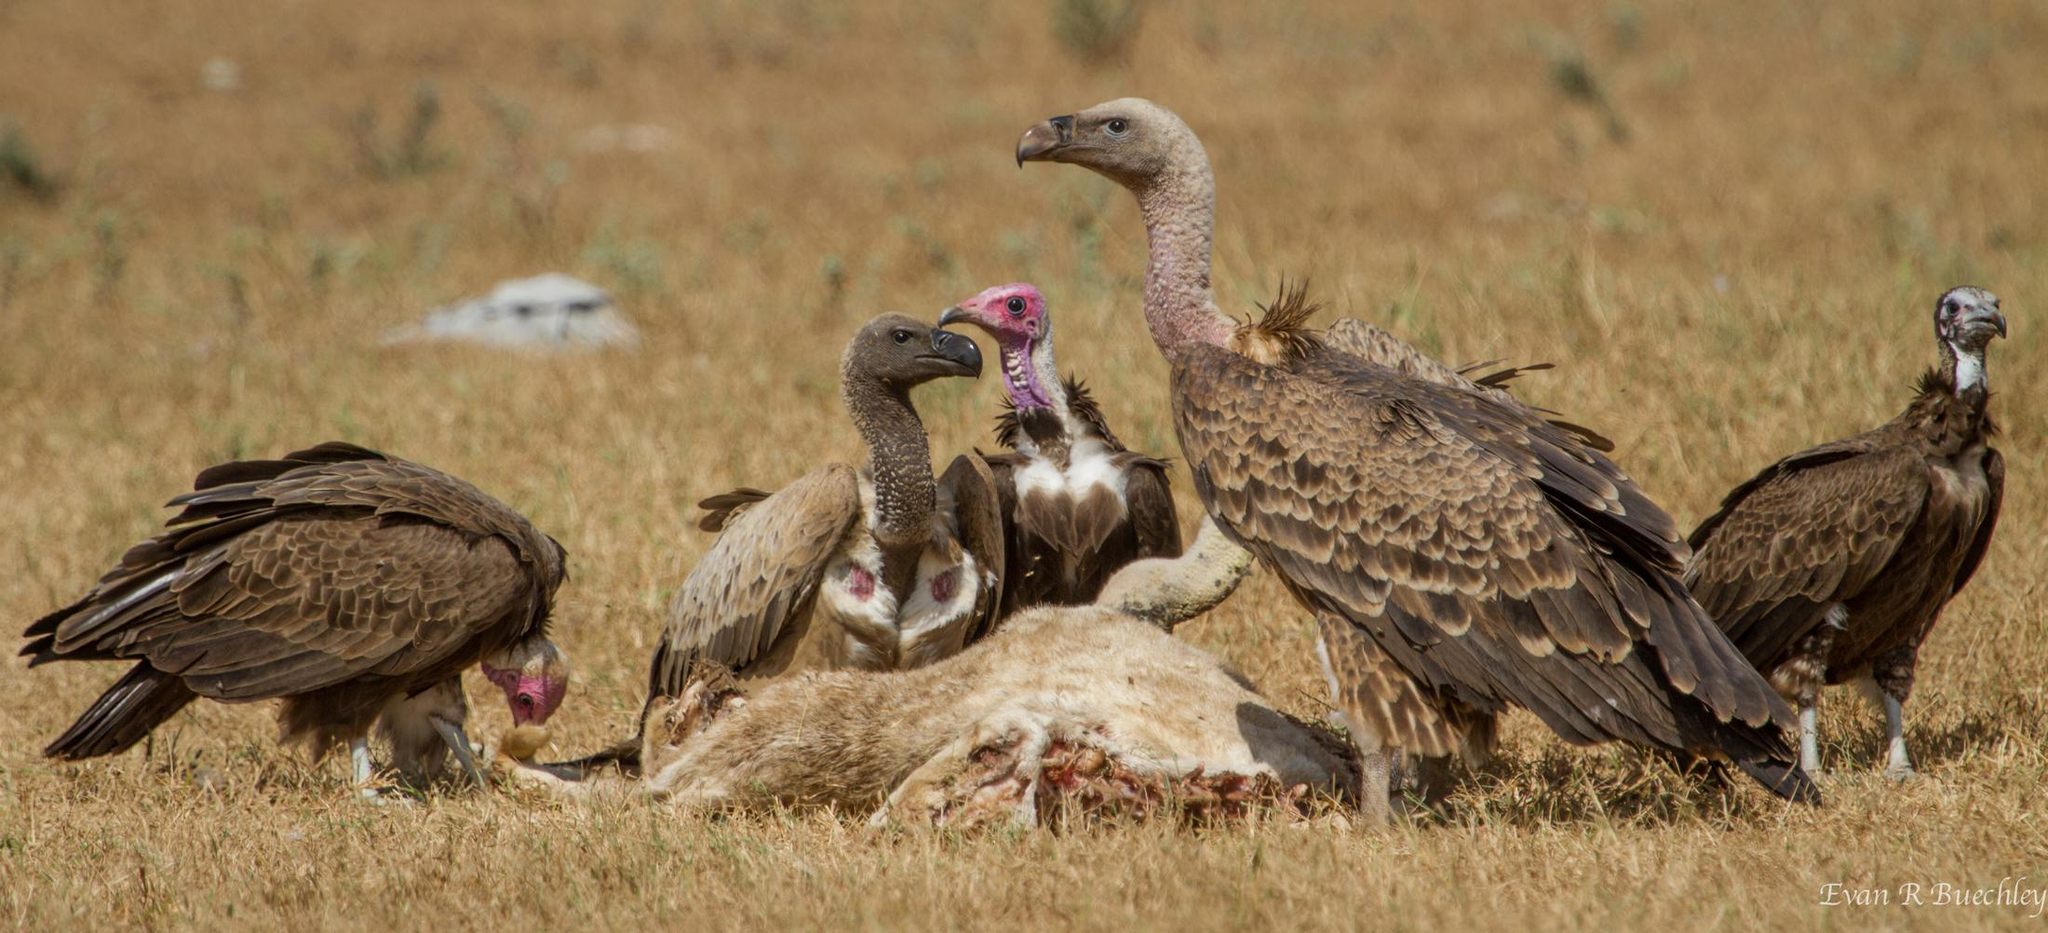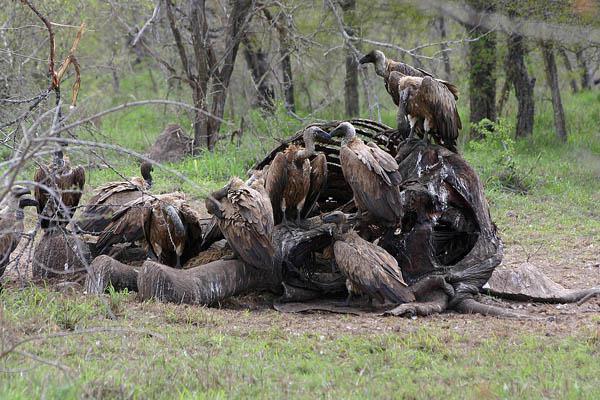The first image is the image on the left, the second image is the image on the right. Examine the images to the left and right. Is the description "An image features no more than four birds gathered around a carcass." accurate? Answer yes or no. No. The first image is the image on the left, the second image is the image on the right. Examine the images to the left and right. Is the description "The sky can be seen in the image on the left" accurate? Answer yes or no. No. 